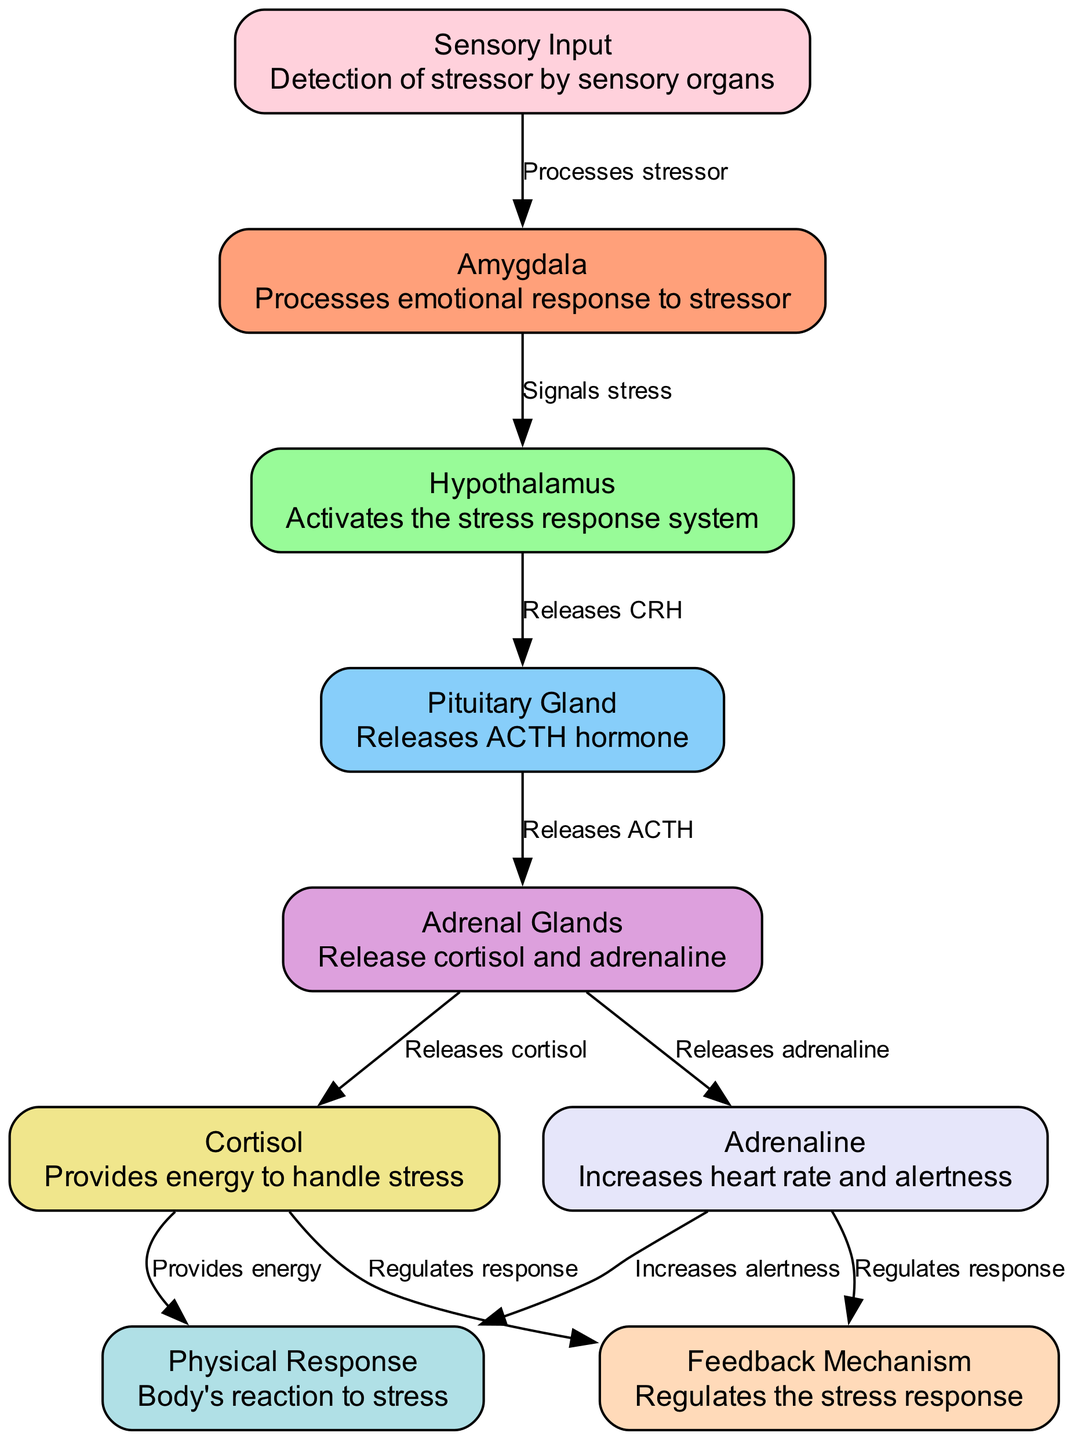What is the role of the hypothalamus? The hypothalamus activates the stress response system, which is indicated in the diagram. It is directly connected to the pituitary gland, showing its function in signaling stress.
Answer: Activates the stress response system How many hormones are released by the adrenal glands? The adrenal glands release two hormones as shown in the diagram: cortisol and adrenaline. The edges connecting the adrenal glands to these two hormones confirm this.
Answer: Two hormones What signals the pituitary gland? The pituitary gland is signaled by the hypothalamus, which releases CRH. This relationship is depicted with a direct edge from the hypothalamus to the pituitary gland, indicating a signaling action.
Answer: Releasing CRH Which two nodes contribute to the feedback mechanism? The feedback mechanism is regulated by both cortisol and adrenaline, as shown by the edges that connect these two nodes to the feedback mechanism. This indicates their role in regulating the stress response.
Answer: Cortisol and adrenaline What is the first step in the stress response mechanism? The first step in the stress response mechanism is the sensory input detected by sensory organs, as depicted in the diagram. It is the starting point for the flow of information regarding stress.
Answer: Sensory input 